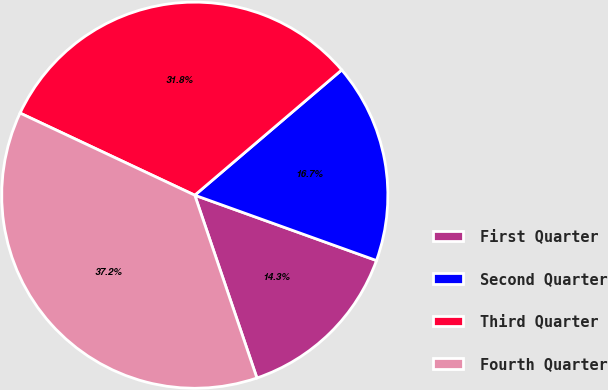<chart> <loc_0><loc_0><loc_500><loc_500><pie_chart><fcel>First Quarter<fcel>Second Quarter<fcel>Third Quarter<fcel>Fourth Quarter<nl><fcel>14.29%<fcel>16.73%<fcel>31.77%<fcel>37.21%<nl></chart> 